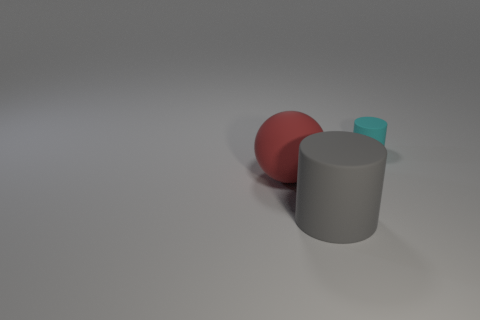There is another matte thing that is the same shape as the small rubber object; what is its size?
Your answer should be compact. Large. How many things are either rubber things to the right of the big red matte ball or large matte objects that are in front of the red ball?
Offer a very short reply. 2. There is a cyan cylinder; does it have the same size as the cylinder in front of the cyan rubber object?
Your response must be concise. No. Is the cylinder that is to the left of the small cyan matte object made of the same material as the large thing that is behind the big gray cylinder?
Provide a short and direct response. Yes. Are there an equal number of tiny rubber objects that are to the right of the cyan rubber object and objects that are on the right side of the big red ball?
Your answer should be compact. No. What number of rubber things are big green things or balls?
Your answer should be very brief. 1. There is a object in front of the large rubber sphere; does it have the same shape as the rubber object right of the large gray matte object?
Provide a short and direct response. Yes. How many big gray things are in front of the cyan cylinder?
Your response must be concise. 1. Are there any large red objects that have the same material as the large cylinder?
Your answer should be very brief. Yes. There is a red object that is the same size as the gray rubber object; what is its material?
Keep it short and to the point. Rubber. 